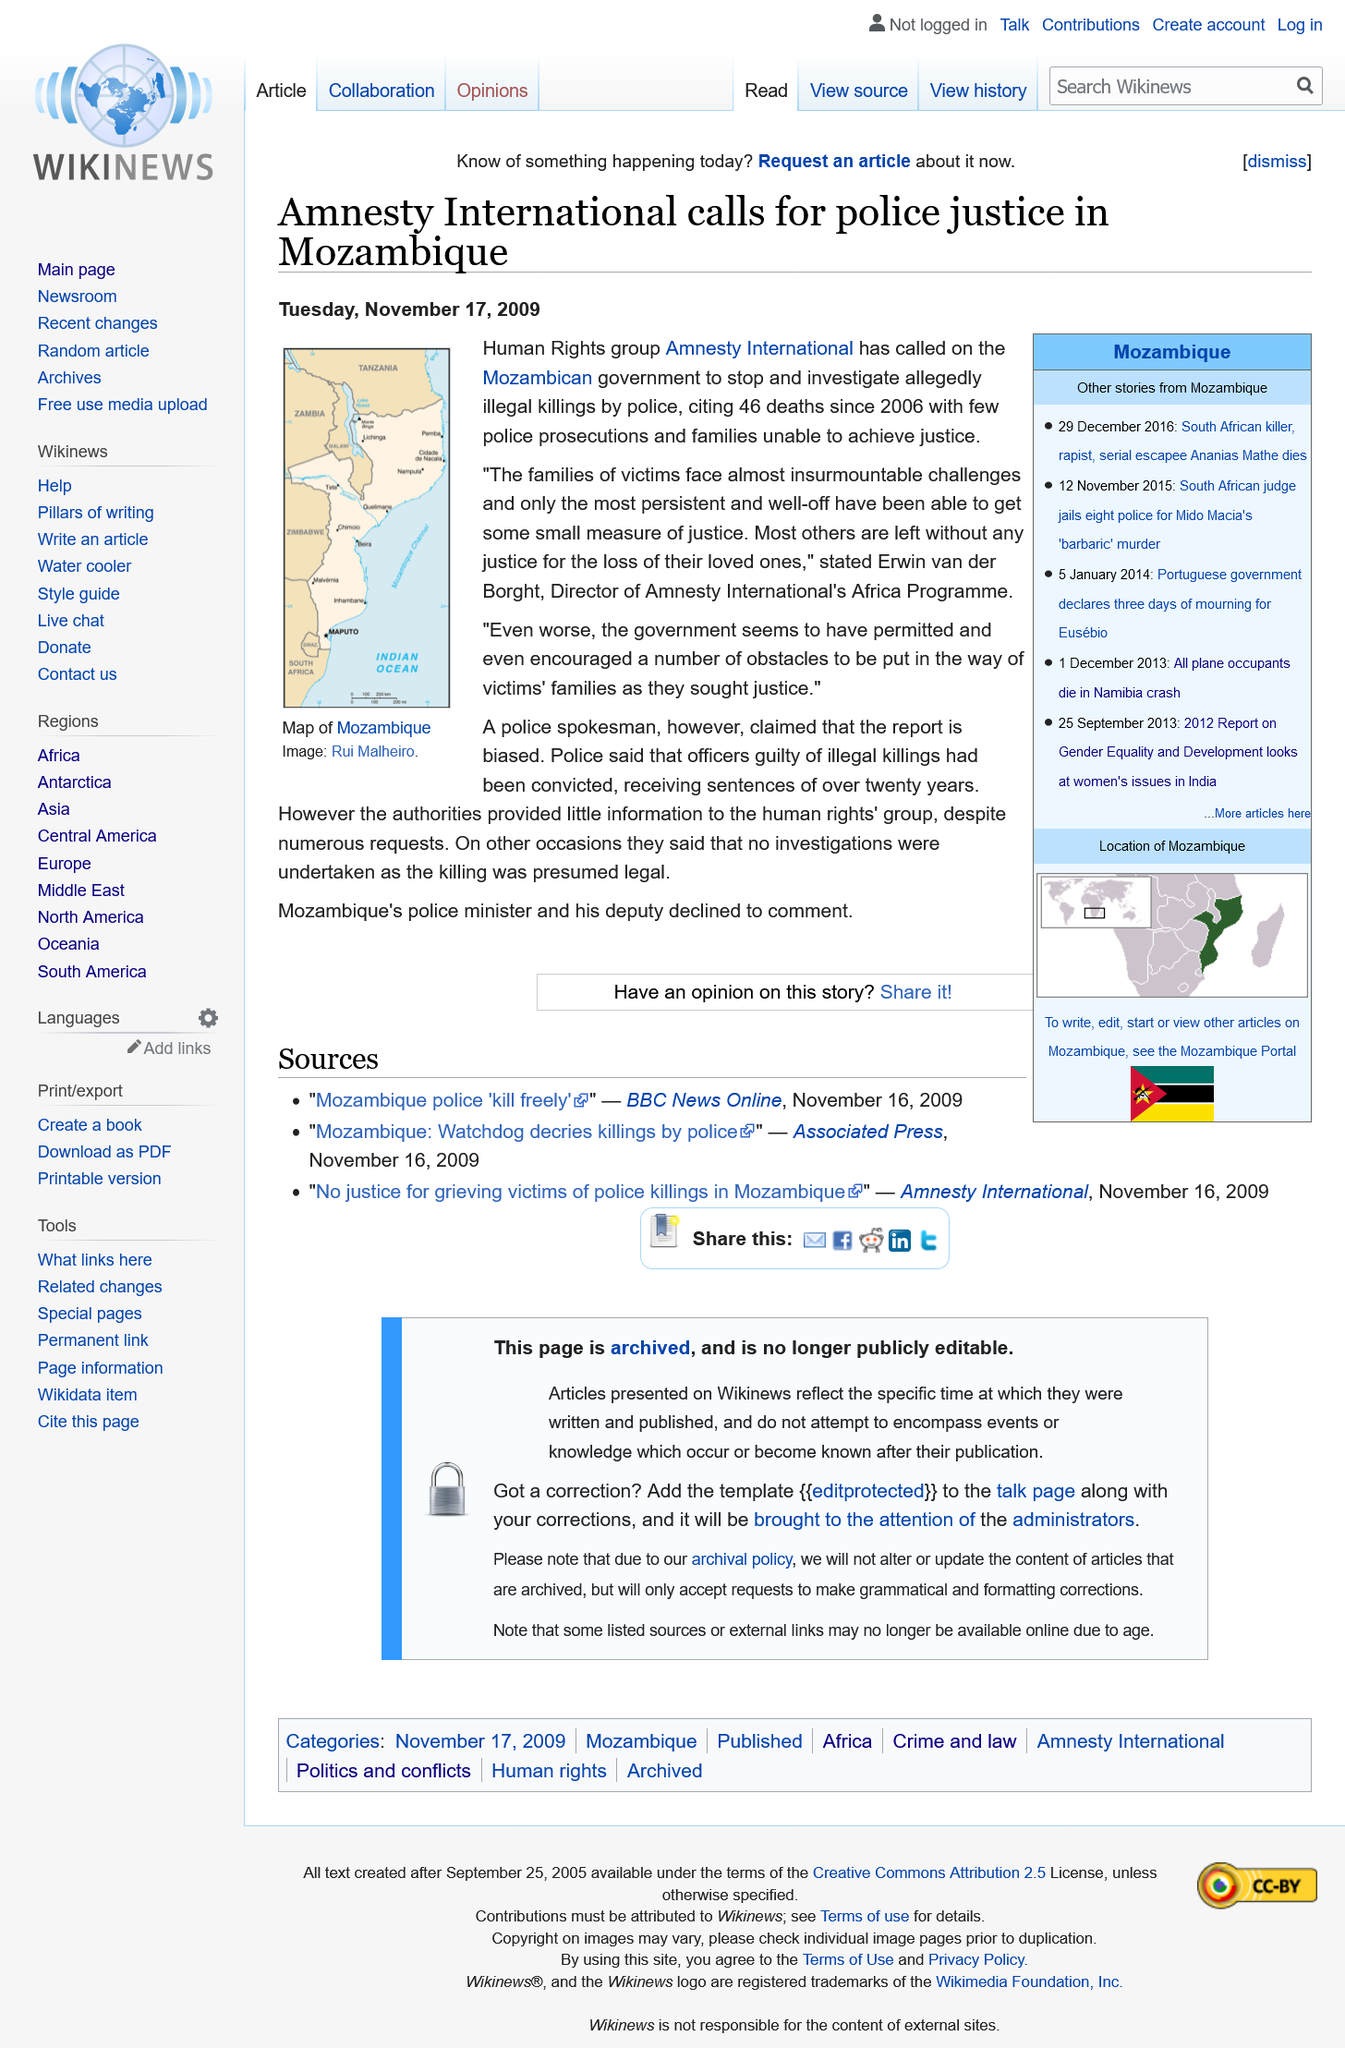Indicate a few pertinent items in this graphic. The police spokesman raised concerns about the report, but did not provide a clear explanation for why. Amnesty International was the human rights group involved in this article. The article was published on Tuesday, November 17, 2009. 